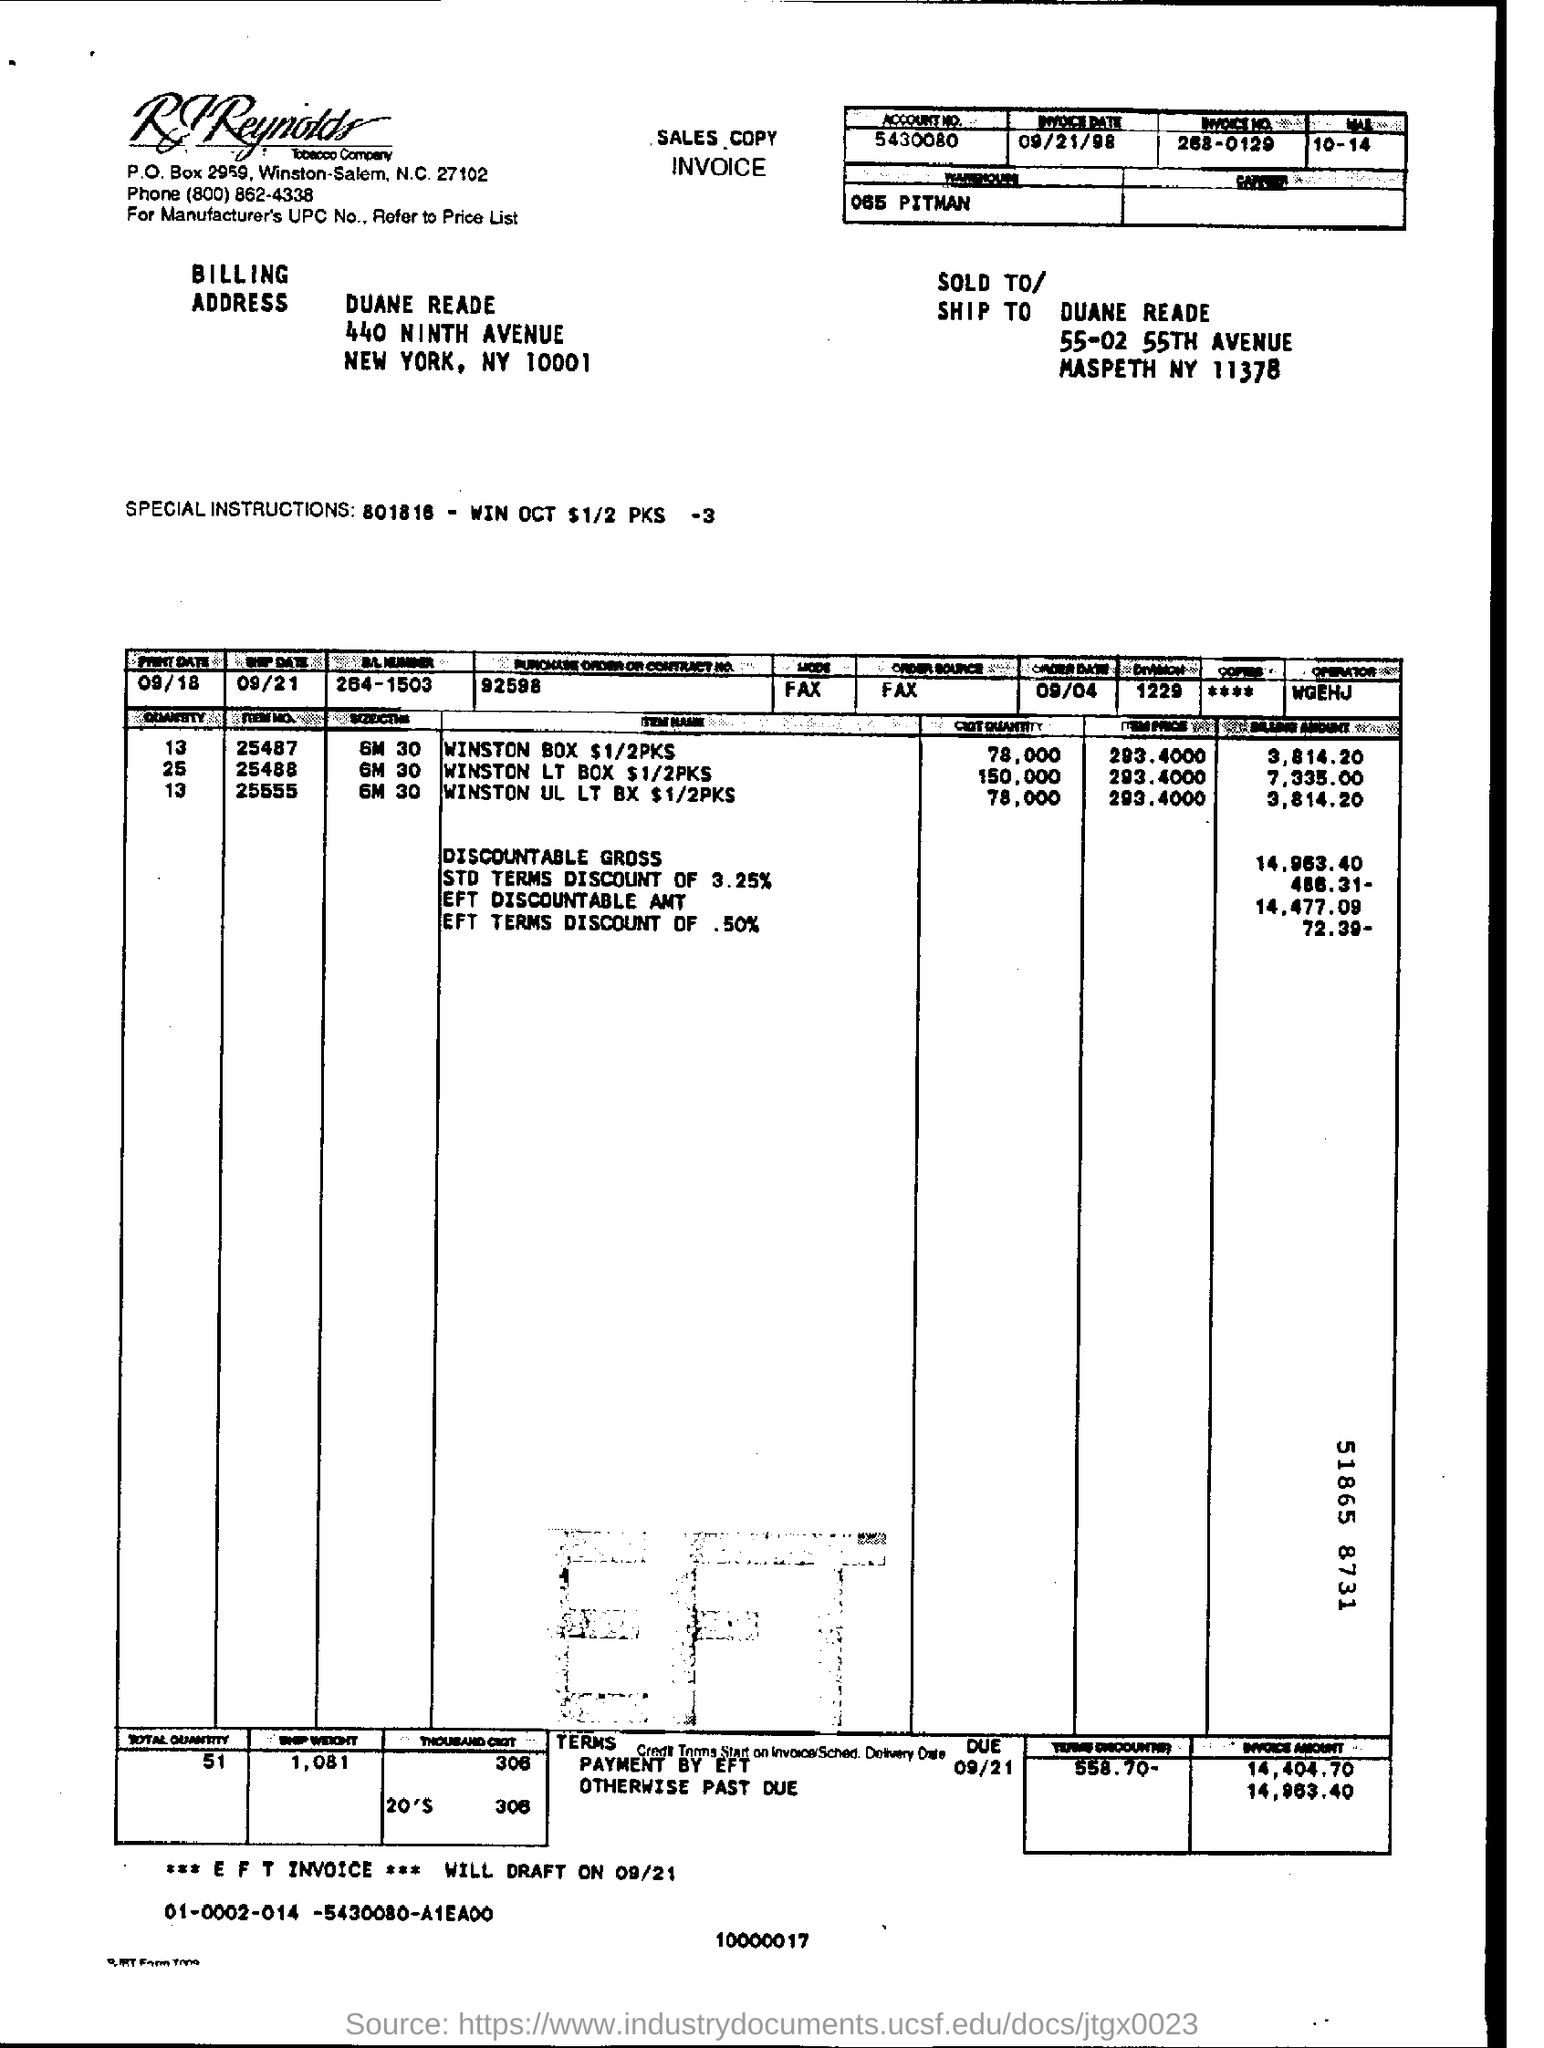What is the account no given in the invoice?
Provide a short and direct response. 5430080. What is the invoice date mentioned in this document?
Your response must be concise. 09/21/98. What is the invoice no. given in the document?
Your answer should be compact. 268-0129. What is the Purchase Order or contract No. given in the invoice?
Offer a very short reply. 92598. 